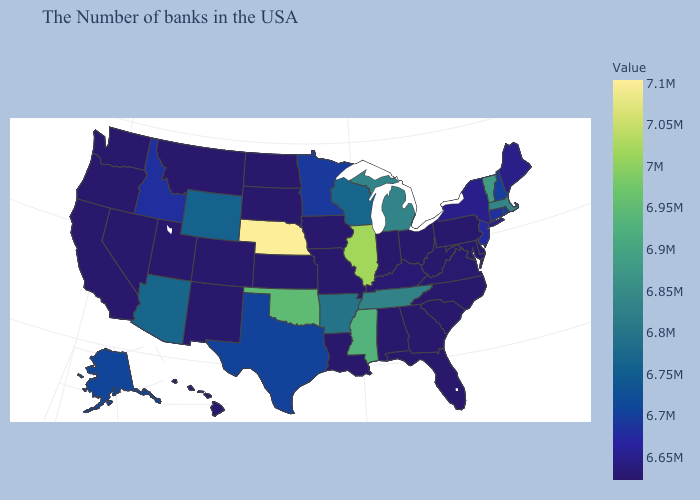Which states have the lowest value in the USA?
Concise answer only. Delaware, Pennsylvania, North Carolina, South Carolina, West Virginia, Ohio, Florida, Georgia, Indiana, Alabama, Louisiana, Missouri, Iowa, Kansas, South Dakota, North Dakota, Colorado, New Mexico, Utah, Montana, Nevada, California, Washington, Oregon, Hawaii. Which states hav the highest value in the West?
Write a very short answer. Arizona. Is the legend a continuous bar?
Be succinct. Yes. Among the states that border Massachusetts , does Connecticut have the highest value?
Keep it brief. No. 